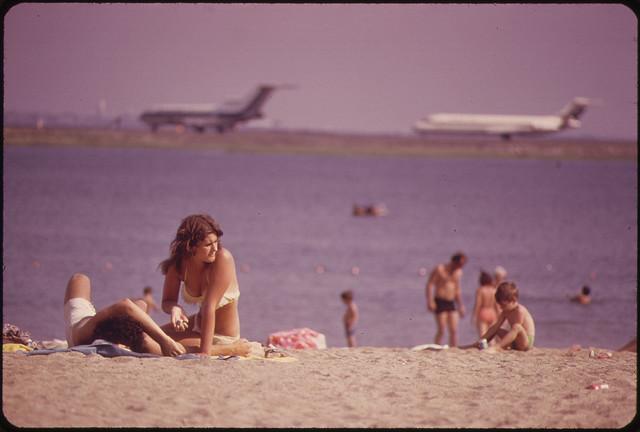Where are these people?
Give a very brief answer. Beach. Is this near an airport?
Concise answer only. Yes. What color is the water?
Write a very short answer. Blue. Is there someone wearing a bikini?
Write a very short answer. Yes. 